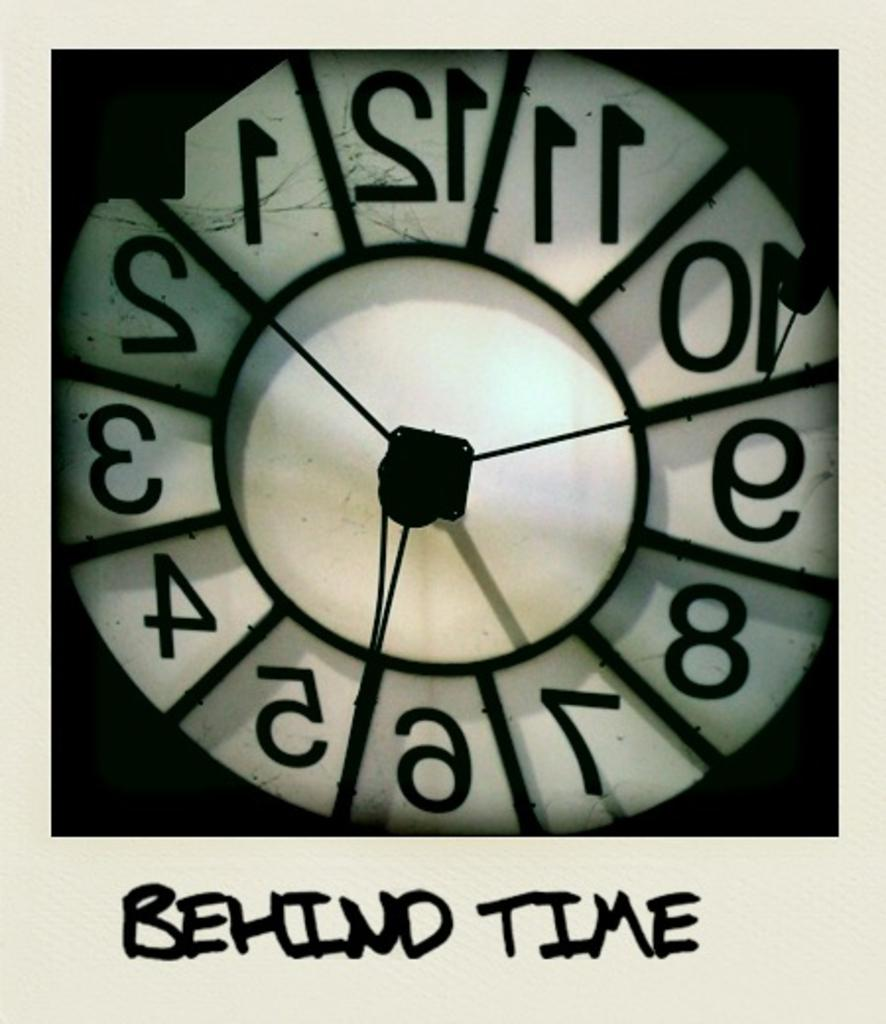<image>
Give a short and clear explanation of the subsequent image. A clock is shown from the back with the caption of Behind Time. 